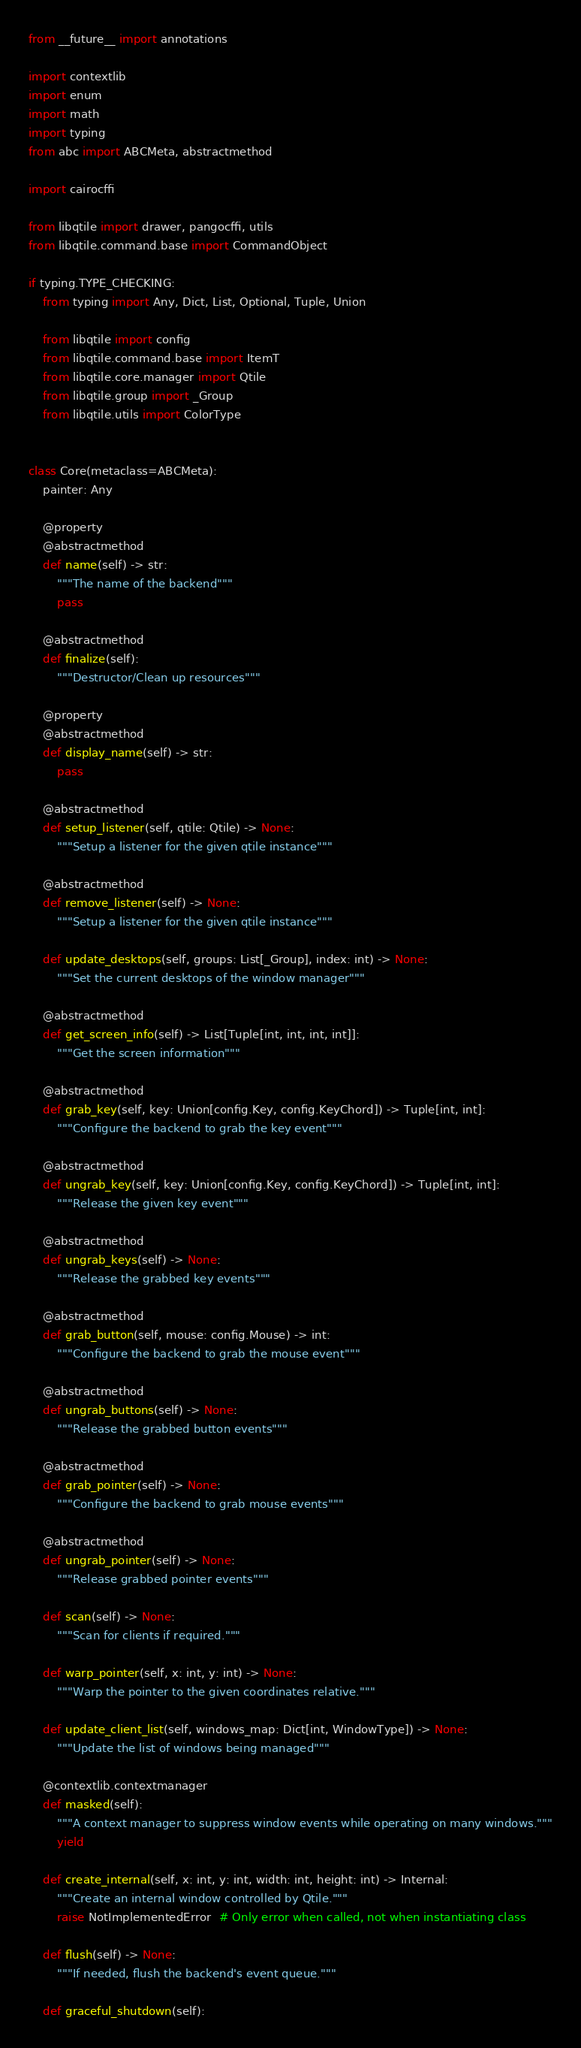<code> <loc_0><loc_0><loc_500><loc_500><_Python_>from __future__ import annotations

import contextlib
import enum
import math
import typing
from abc import ABCMeta, abstractmethod

import cairocffi

from libqtile import drawer, pangocffi, utils
from libqtile.command.base import CommandObject

if typing.TYPE_CHECKING:
    from typing import Any, Dict, List, Optional, Tuple, Union

    from libqtile import config
    from libqtile.command.base import ItemT
    from libqtile.core.manager import Qtile
    from libqtile.group import _Group
    from libqtile.utils import ColorType


class Core(metaclass=ABCMeta):
    painter: Any

    @property
    @abstractmethod
    def name(self) -> str:
        """The name of the backend"""
        pass

    @abstractmethod
    def finalize(self):
        """Destructor/Clean up resources"""

    @property
    @abstractmethod
    def display_name(self) -> str:
        pass

    @abstractmethod
    def setup_listener(self, qtile: Qtile) -> None:
        """Setup a listener for the given qtile instance"""

    @abstractmethod
    def remove_listener(self) -> None:
        """Setup a listener for the given qtile instance"""

    def update_desktops(self, groups: List[_Group], index: int) -> None:
        """Set the current desktops of the window manager"""

    @abstractmethod
    def get_screen_info(self) -> List[Tuple[int, int, int, int]]:
        """Get the screen information"""

    @abstractmethod
    def grab_key(self, key: Union[config.Key, config.KeyChord]) -> Tuple[int, int]:
        """Configure the backend to grab the key event"""

    @abstractmethod
    def ungrab_key(self, key: Union[config.Key, config.KeyChord]) -> Tuple[int, int]:
        """Release the given key event"""

    @abstractmethod
    def ungrab_keys(self) -> None:
        """Release the grabbed key events"""

    @abstractmethod
    def grab_button(self, mouse: config.Mouse) -> int:
        """Configure the backend to grab the mouse event"""

    @abstractmethod
    def ungrab_buttons(self) -> None:
        """Release the grabbed button events"""

    @abstractmethod
    def grab_pointer(self) -> None:
        """Configure the backend to grab mouse events"""

    @abstractmethod
    def ungrab_pointer(self) -> None:
        """Release grabbed pointer events"""

    def scan(self) -> None:
        """Scan for clients if required."""

    def warp_pointer(self, x: int, y: int) -> None:
        """Warp the pointer to the given coordinates relative."""

    def update_client_list(self, windows_map: Dict[int, WindowType]) -> None:
        """Update the list of windows being managed"""

    @contextlib.contextmanager
    def masked(self):
        """A context manager to suppress window events while operating on many windows."""
        yield

    def create_internal(self, x: int, y: int, width: int, height: int) -> Internal:
        """Create an internal window controlled by Qtile."""
        raise NotImplementedError  # Only error when called, not when instantiating class

    def flush(self) -> None:
        """If needed, flush the backend's event queue."""

    def graceful_shutdown(self):</code> 